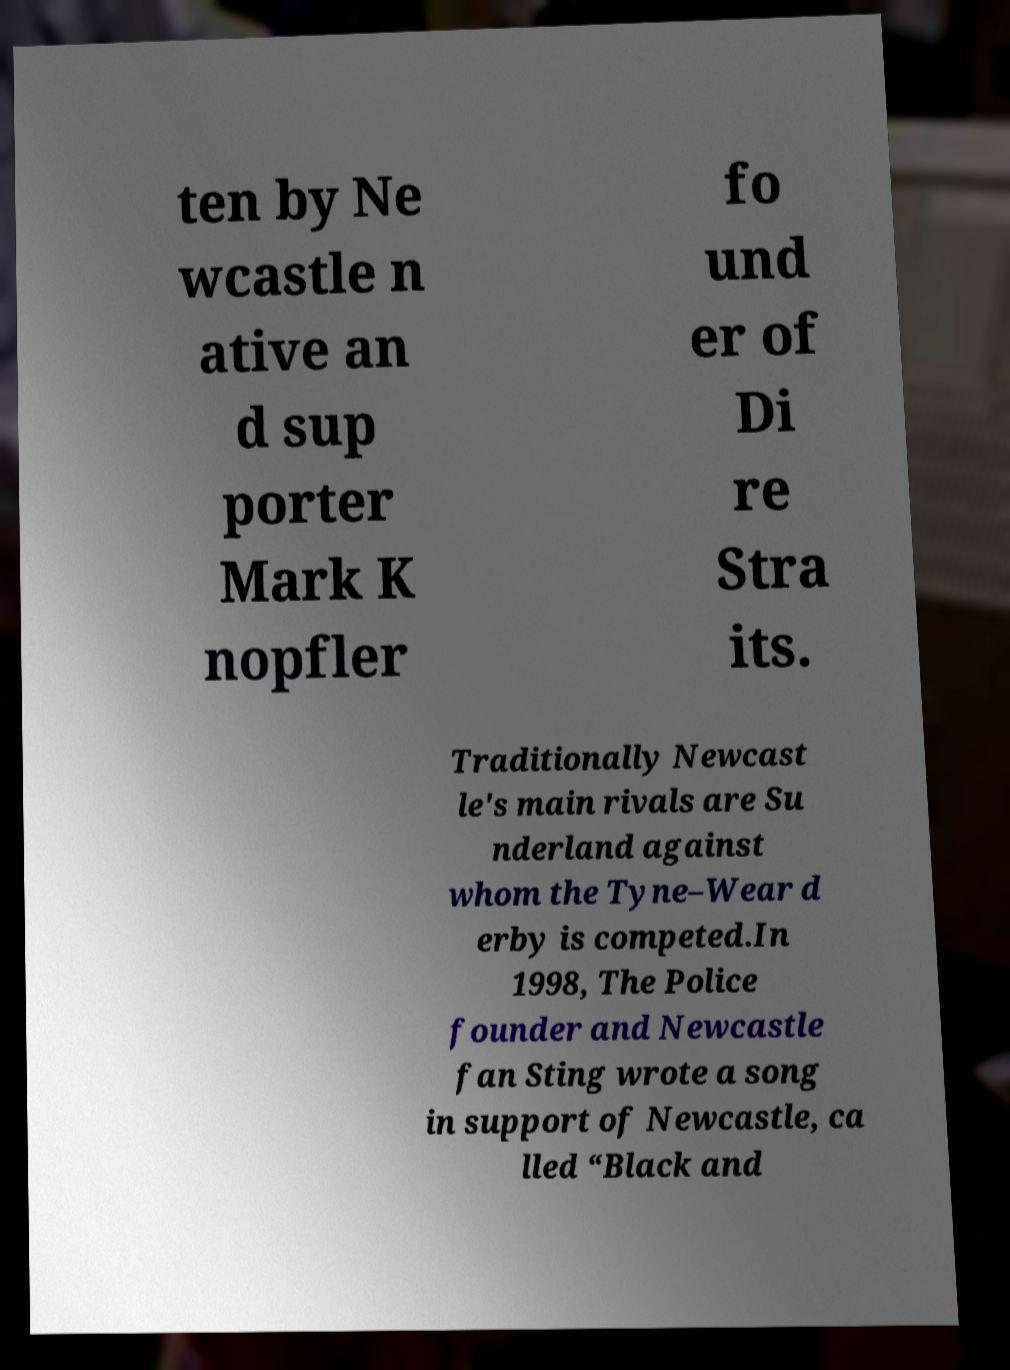Please read and relay the text visible in this image. What does it say? ten by Ne wcastle n ative an d sup porter Mark K nopfler fo und er of Di re Stra its. Traditionally Newcast le's main rivals are Su nderland against whom the Tyne–Wear d erby is competed.In 1998, The Police founder and Newcastle fan Sting wrote a song in support of Newcastle, ca lled “Black and 